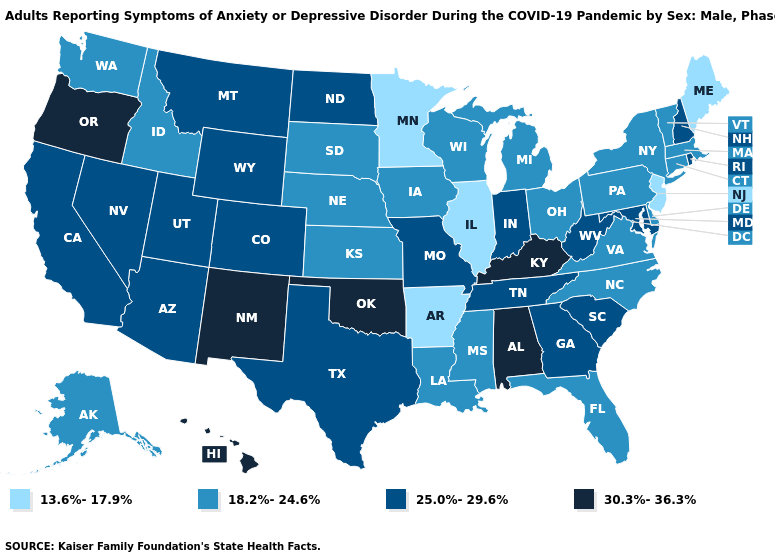Name the states that have a value in the range 30.3%-36.3%?
Give a very brief answer. Alabama, Hawaii, Kentucky, New Mexico, Oklahoma, Oregon. What is the value of Idaho?
Give a very brief answer. 18.2%-24.6%. What is the value of Oregon?
Keep it brief. 30.3%-36.3%. How many symbols are there in the legend?
Give a very brief answer. 4. Does Oregon have the highest value in the West?
Give a very brief answer. Yes. What is the value of Illinois?
Write a very short answer. 13.6%-17.9%. Does New Jersey have a lower value than Illinois?
Write a very short answer. No. How many symbols are there in the legend?
Be succinct. 4. Name the states that have a value in the range 13.6%-17.9%?
Keep it brief. Arkansas, Illinois, Maine, Minnesota, New Jersey. Does New Hampshire have the lowest value in the USA?
Give a very brief answer. No. Does Oklahoma have the highest value in the USA?
Concise answer only. Yes. What is the value of Nebraska?
Concise answer only. 18.2%-24.6%. Name the states that have a value in the range 25.0%-29.6%?
Give a very brief answer. Arizona, California, Colorado, Georgia, Indiana, Maryland, Missouri, Montana, Nevada, New Hampshire, North Dakota, Rhode Island, South Carolina, Tennessee, Texas, Utah, West Virginia, Wyoming. 